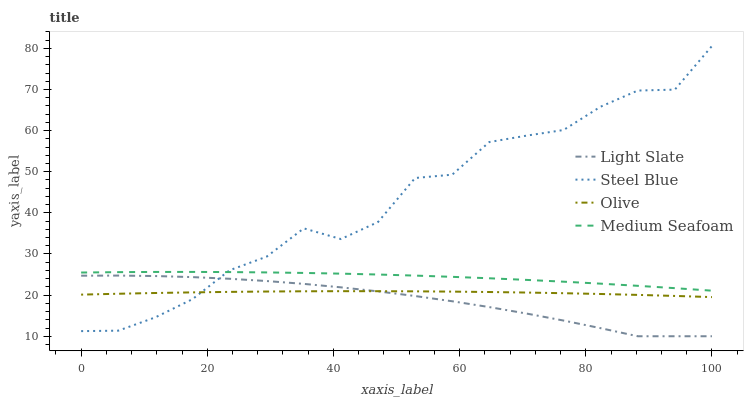Does Light Slate have the minimum area under the curve?
Answer yes or no. Yes. Does Steel Blue have the maximum area under the curve?
Answer yes or no. Yes. Does Olive have the minimum area under the curve?
Answer yes or no. No. Does Olive have the maximum area under the curve?
Answer yes or no. No. Is Olive the smoothest?
Answer yes or no. Yes. Is Steel Blue the roughest?
Answer yes or no. Yes. Is Steel Blue the smoothest?
Answer yes or no. No. Is Olive the roughest?
Answer yes or no. No. Does Olive have the lowest value?
Answer yes or no. No. Does Olive have the highest value?
Answer yes or no. No. Is Olive less than Medium Seafoam?
Answer yes or no. Yes. Is Medium Seafoam greater than Light Slate?
Answer yes or no. Yes. Does Olive intersect Medium Seafoam?
Answer yes or no. No. 